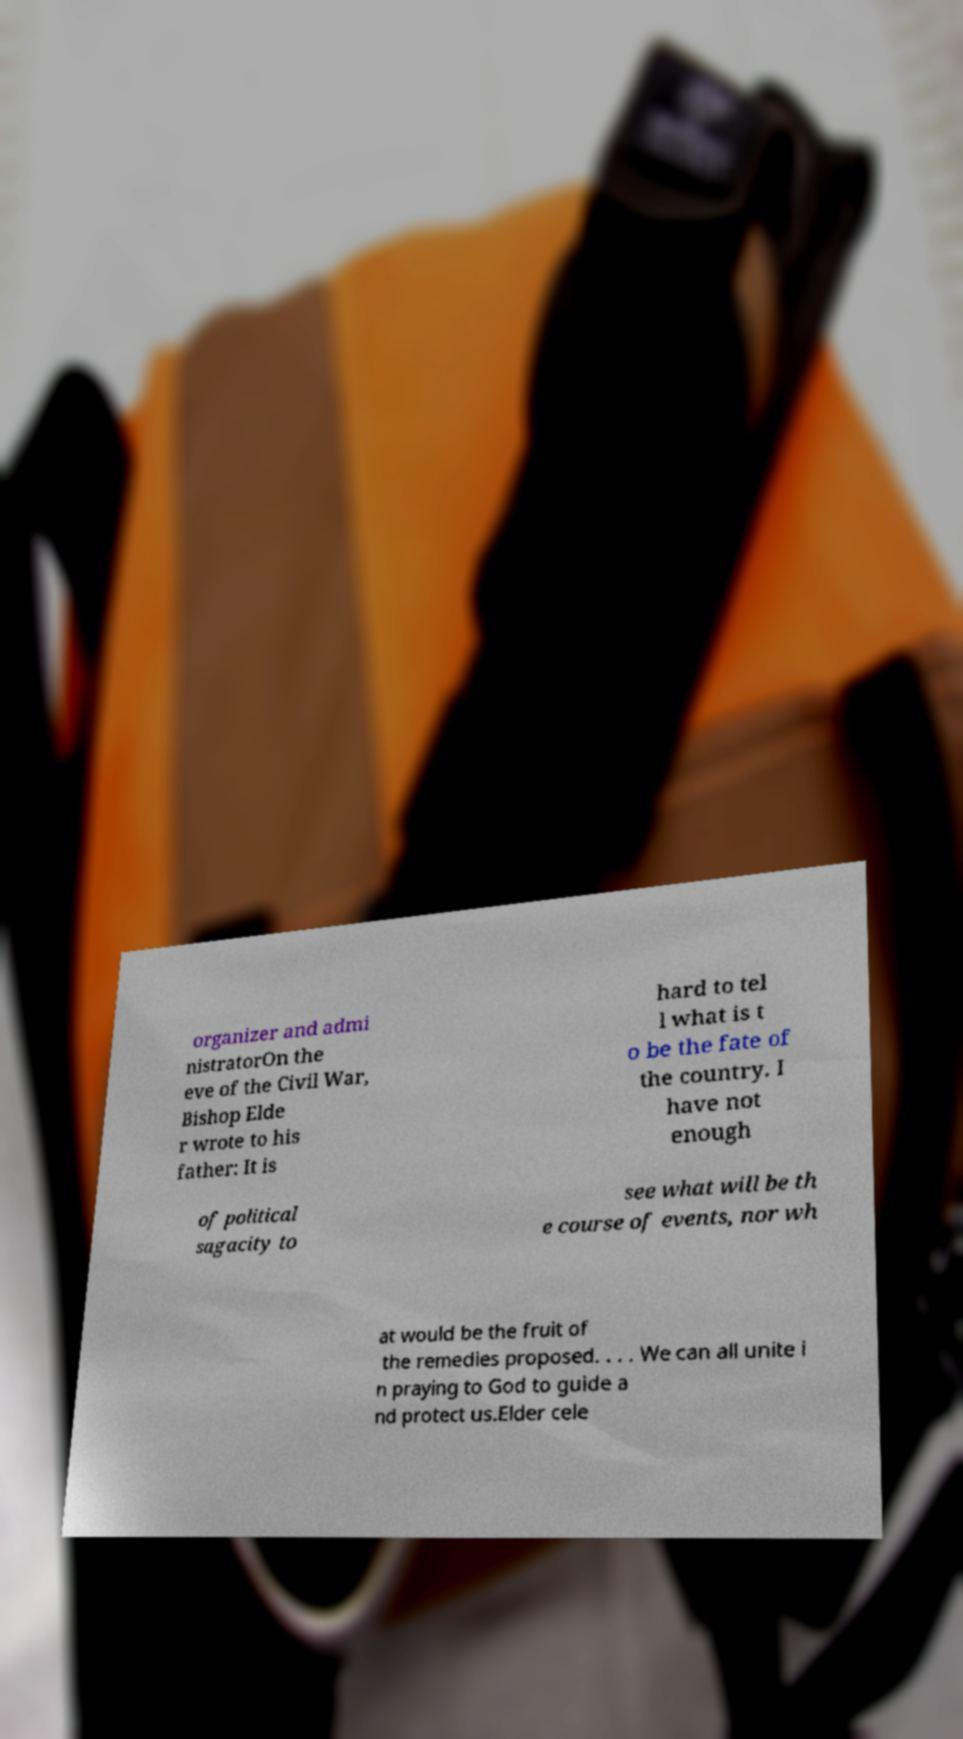Please read and relay the text visible in this image. What does it say? organizer and admi nistratorOn the eve of the Civil War, Bishop Elde r wrote to his father: It is hard to tel l what is t o be the fate of the country. I have not enough of political sagacity to see what will be th e course of events, nor wh at would be the fruit of the remedies proposed. . . . We can all unite i n praying to God to guide a nd protect us.Elder cele 